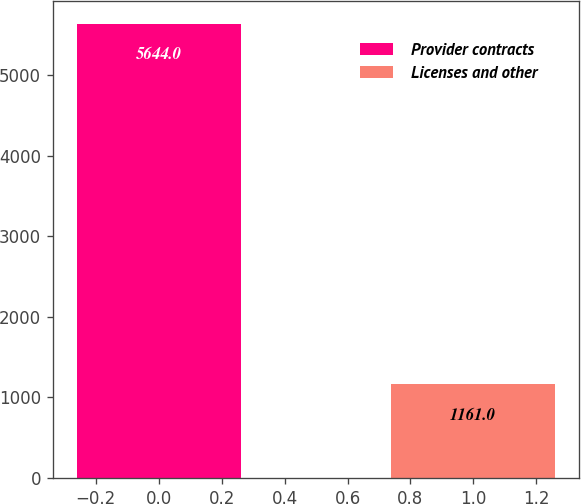Convert chart. <chart><loc_0><loc_0><loc_500><loc_500><bar_chart><fcel>Provider contracts<fcel>Licenses and other<nl><fcel>5644<fcel>1161<nl></chart> 